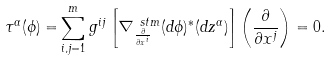<formula> <loc_0><loc_0><loc_500><loc_500>\tau ^ { \alpha } ( \phi ) = & \sum _ { i , j = 1 } ^ { m } g ^ { i j } \left [ \nabla ^ { \ s t m } _ { \frac { \partial } { \partial x ^ { i } } } ( d \phi ) ^ { \ast } ( d z ^ { \alpha } ) \right ] \left ( \frac { \partial } { \partial x ^ { j } } \right ) = 0 .</formula> 